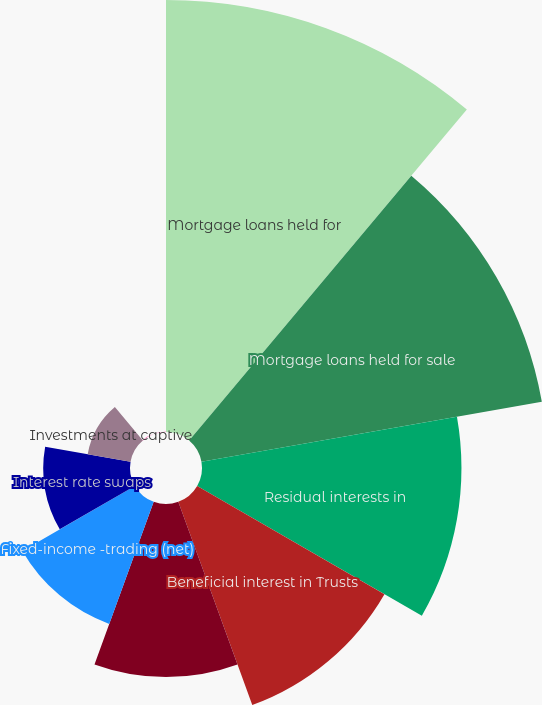<chart> <loc_0><loc_0><loc_500><loc_500><pie_chart><fcel>Mortgage loans held for<fcel>Mortgage loans held for sale<fcel>Residual interests in<fcel>Beneficial interest in Trusts<fcel>Mortgage-backed securities<fcel>Fixed-income -trading (net)<fcel>Interest rate swaps<fcel>Investments at captive<fcel>Put options on Eurodollar<nl><fcel>25.61%<fcel>20.49%<fcel>15.38%<fcel>12.82%<fcel>10.26%<fcel>7.7%<fcel>5.14%<fcel>2.58%<fcel>0.02%<nl></chart> 